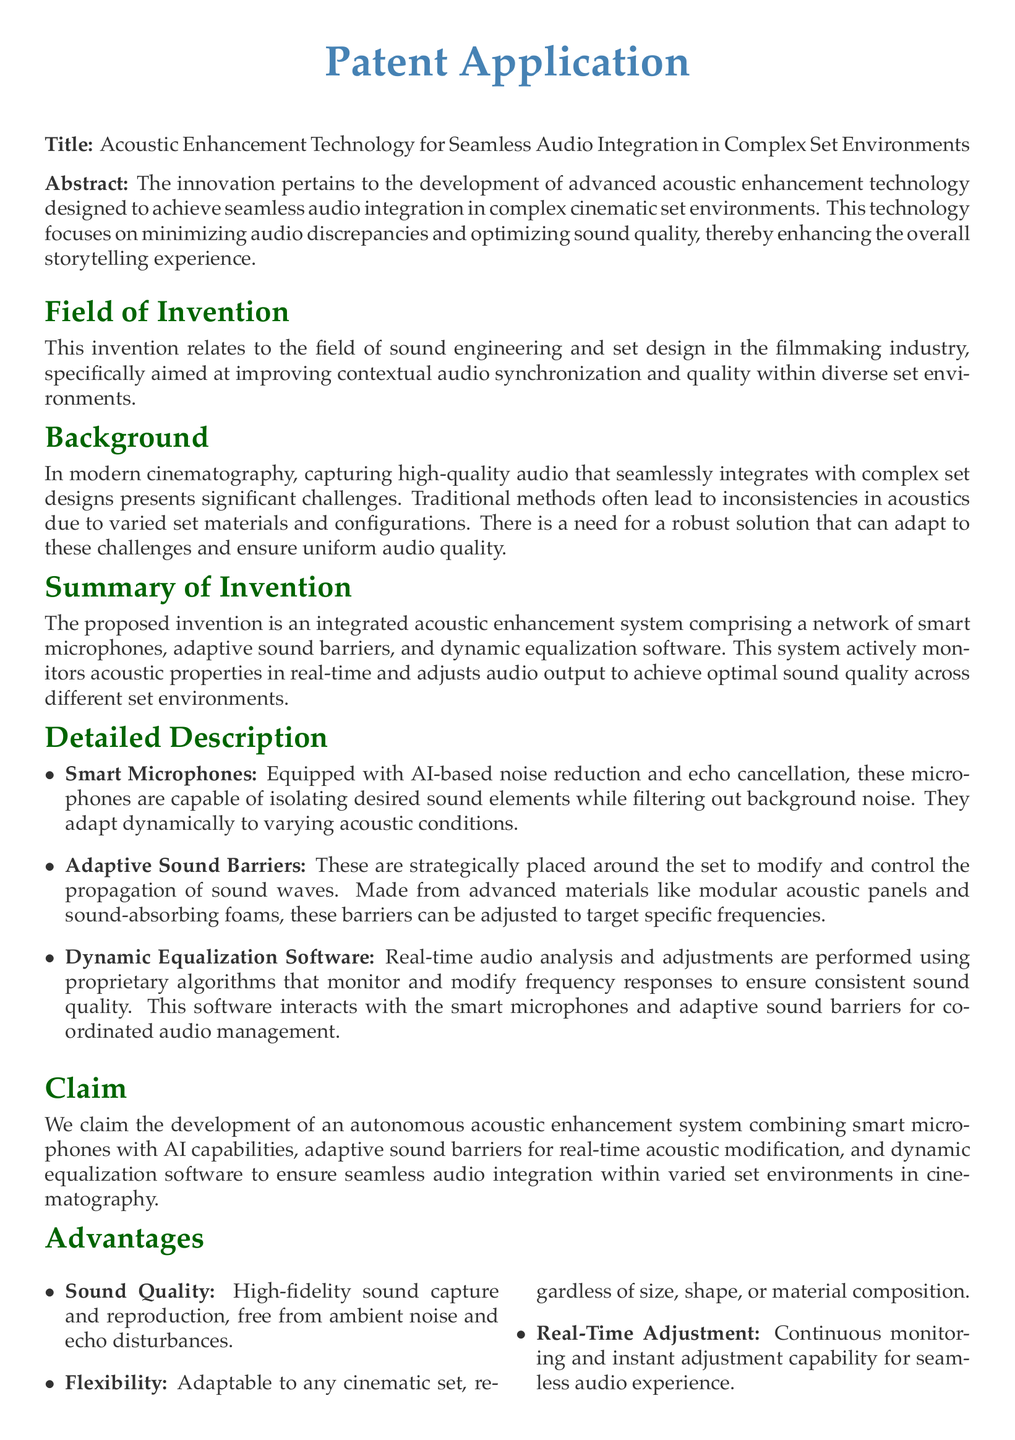What is the title of the patent application? The title is specified in the document as the main heading and reflects the focus of the invention.
Answer: Acoustic Enhancement Technology for Seamless Audio Integration in Complex Set Environments What technology does the invention focus on? The abstract describes the primary aim of the invention related to auditory improvements within set environments.
Answer: Acoustic enhancement technology What are smart microphones designed to do? The detailed description explains the functionality and capabilities of smart microphones in the system.
Answer: Isolate desired sound elements What is the role of adaptive sound barriers? The detailed description outlines the function of adaptive sound barriers in managing sound propagation.
Answer: Control the propagation of sound waves What is one application of this technology mentioned? The potential applications section lists specific uses of the technology in various contexts.
Answer: Film production How does the dynamic equalization software operate? The detailed description indicates how the software interacts with other components to ensure audio quality.
Answer: Performs real-time audio analysis What advantage does this technology offer regarding sound quality? The advantages section highlights specific benefits related to audio reproduction and disturbances.
Answer: High-fidelity sound capture How does the system accommodate different set environments? The summary of the invention describes the key feature that allows adaptation to diverse conditions.
Answer: Flexibility What type of noise reduction does the technology incorporate? The detailed description refers to the capabilities of the smart microphones in noise handling.
Answer: AI-based noise reduction What does the conclusion emphasize about the invention? The conclusion summarizes the impact of the invention on the auditory experience in filmmaking.
Answer: Enhancing the overall auditory experience 